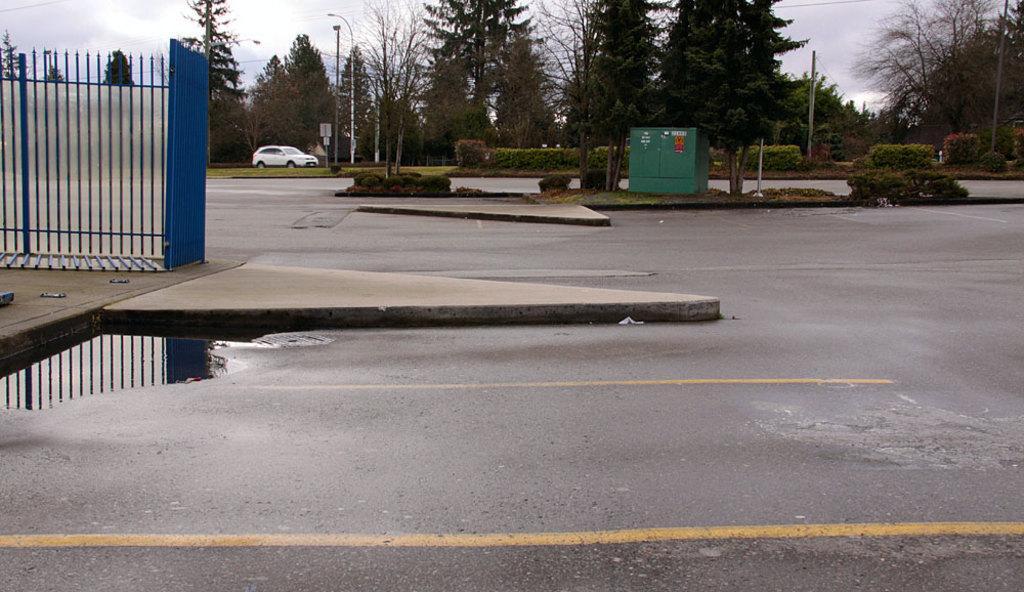Could you give a brief overview of what you see in this image? In a given image I can see a fence, road, trees, plants, vehicle, light poles and some other objects. 